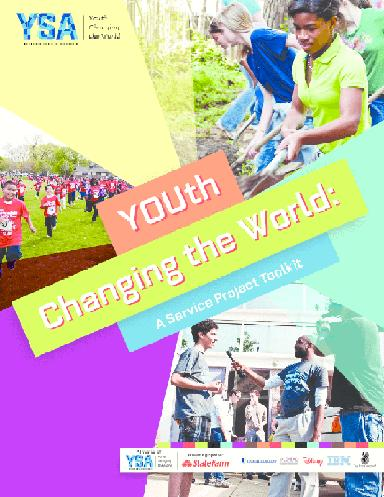What partners are involved with YSA as shown on the brochure? The YSA brochure showcases logos from several partners in supporting youth service initiatives, such as State Farm, Sodexo, the Corporation for National and Community Service, and Disney. These partnerships indicate a collaborative effort with corporations and other organizations to foster a culture of service among the youth and to expand the reach and effectiveness of YSA's programs and resources. 